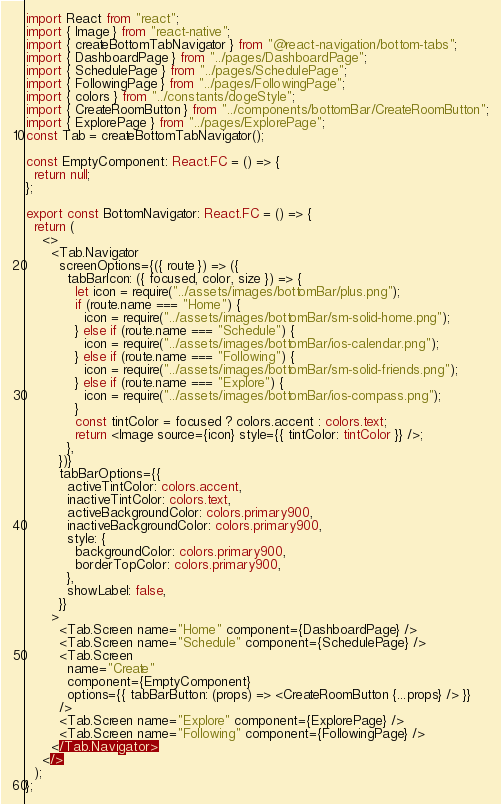Convert code to text. <code><loc_0><loc_0><loc_500><loc_500><_TypeScript_>import React from "react";
import { Image } from "react-native";
import { createBottomTabNavigator } from "@react-navigation/bottom-tabs";
import { DashboardPage } from "../pages/DashboardPage";
import { SchedulePage } from "../pages/SchedulePage";
import { FollowingPage } from "../pages/FollowingPage";
import { colors } from "../constants/dogeStyle";
import { CreateRoomButton } from "../components/bottomBar/CreateRoomButton";
import { ExplorePage } from "../pages/ExplorePage";
const Tab = createBottomTabNavigator();

const EmptyComponent: React.FC = () => {
  return null;
};

export const BottomNavigator: React.FC = () => {
  return (
    <>
      <Tab.Navigator
        screenOptions={({ route }) => ({
          tabBarIcon: ({ focused, color, size }) => {
            let icon = require("../assets/images/bottomBar/plus.png");
            if (route.name === "Home") {
              icon = require("../assets/images/bottomBar/sm-solid-home.png");
            } else if (route.name === "Schedule") {
              icon = require("../assets/images/bottomBar/ios-calendar.png");
            } else if (route.name === "Following") {
              icon = require("../assets/images/bottomBar/sm-solid-friends.png");
            } else if (route.name === "Explore") {
              icon = require("../assets/images/bottomBar/ios-compass.png");
            }
            const tintColor = focused ? colors.accent : colors.text;
            return <Image source={icon} style={{ tintColor: tintColor }} />;
          },
        })}
        tabBarOptions={{
          activeTintColor: colors.accent,
          inactiveTintColor: colors.text,
          activeBackgroundColor: colors.primary900,
          inactiveBackgroundColor: colors.primary900,
          style: {
            backgroundColor: colors.primary900,
            borderTopColor: colors.primary900,
          },
          showLabel: false,
        }}
      >
        <Tab.Screen name="Home" component={DashboardPage} />
        <Tab.Screen name="Schedule" component={SchedulePage} />
        <Tab.Screen
          name="Create"
          component={EmptyComponent}
          options={{ tabBarButton: (props) => <CreateRoomButton {...props} /> }}
        />
        <Tab.Screen name="Explore" component={ExplorePage} />
        <Tab.Screen name="Following" component={FollowingPage} />
      </Tab.Navigator>
    </>
  );
};
</code> 